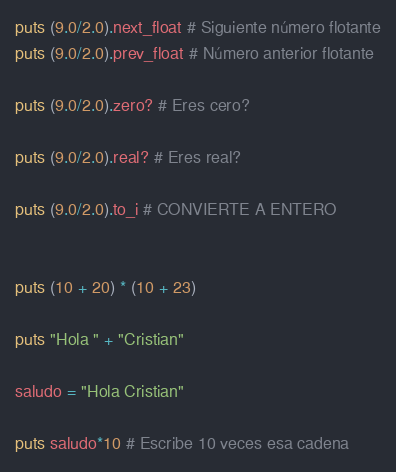<code> <loc_0><loc_0><loc_500><loc_500><_Ruby_>puts (9.0/2.0).next_float # Siguiente número flotante
puts (9.0/2.0).prev_float # Número anterior flotante

puts (9.0/2.0).zero? # Eres cero?

puts (9.0/2.0).real? # Eres real?

puts (9.0/2.0).to_i # CONVIERTE A ENTERO


puts (10 + 20) * (10 + 23)

puts "Hola " + "Cristian"

saludo = "Hola Cristian"

puts saludo*10 # Escribe 10 veces esa cadena
</code> 